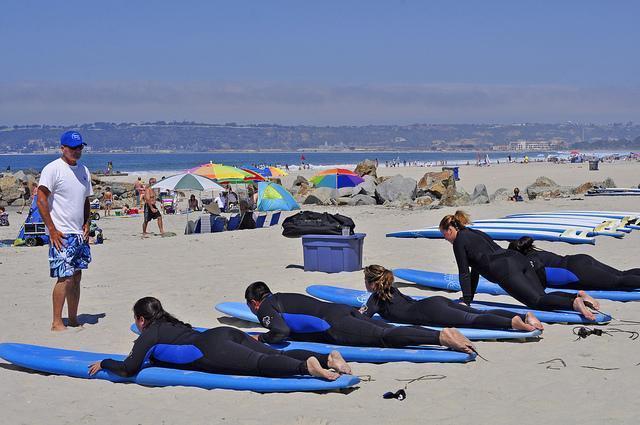How many surfboards can be seen?
Give a very brief answer. 3. How many people can you see?
Give a very brief answer. 6. How many birds are in the picture?
Give a very brief answer. 0. 